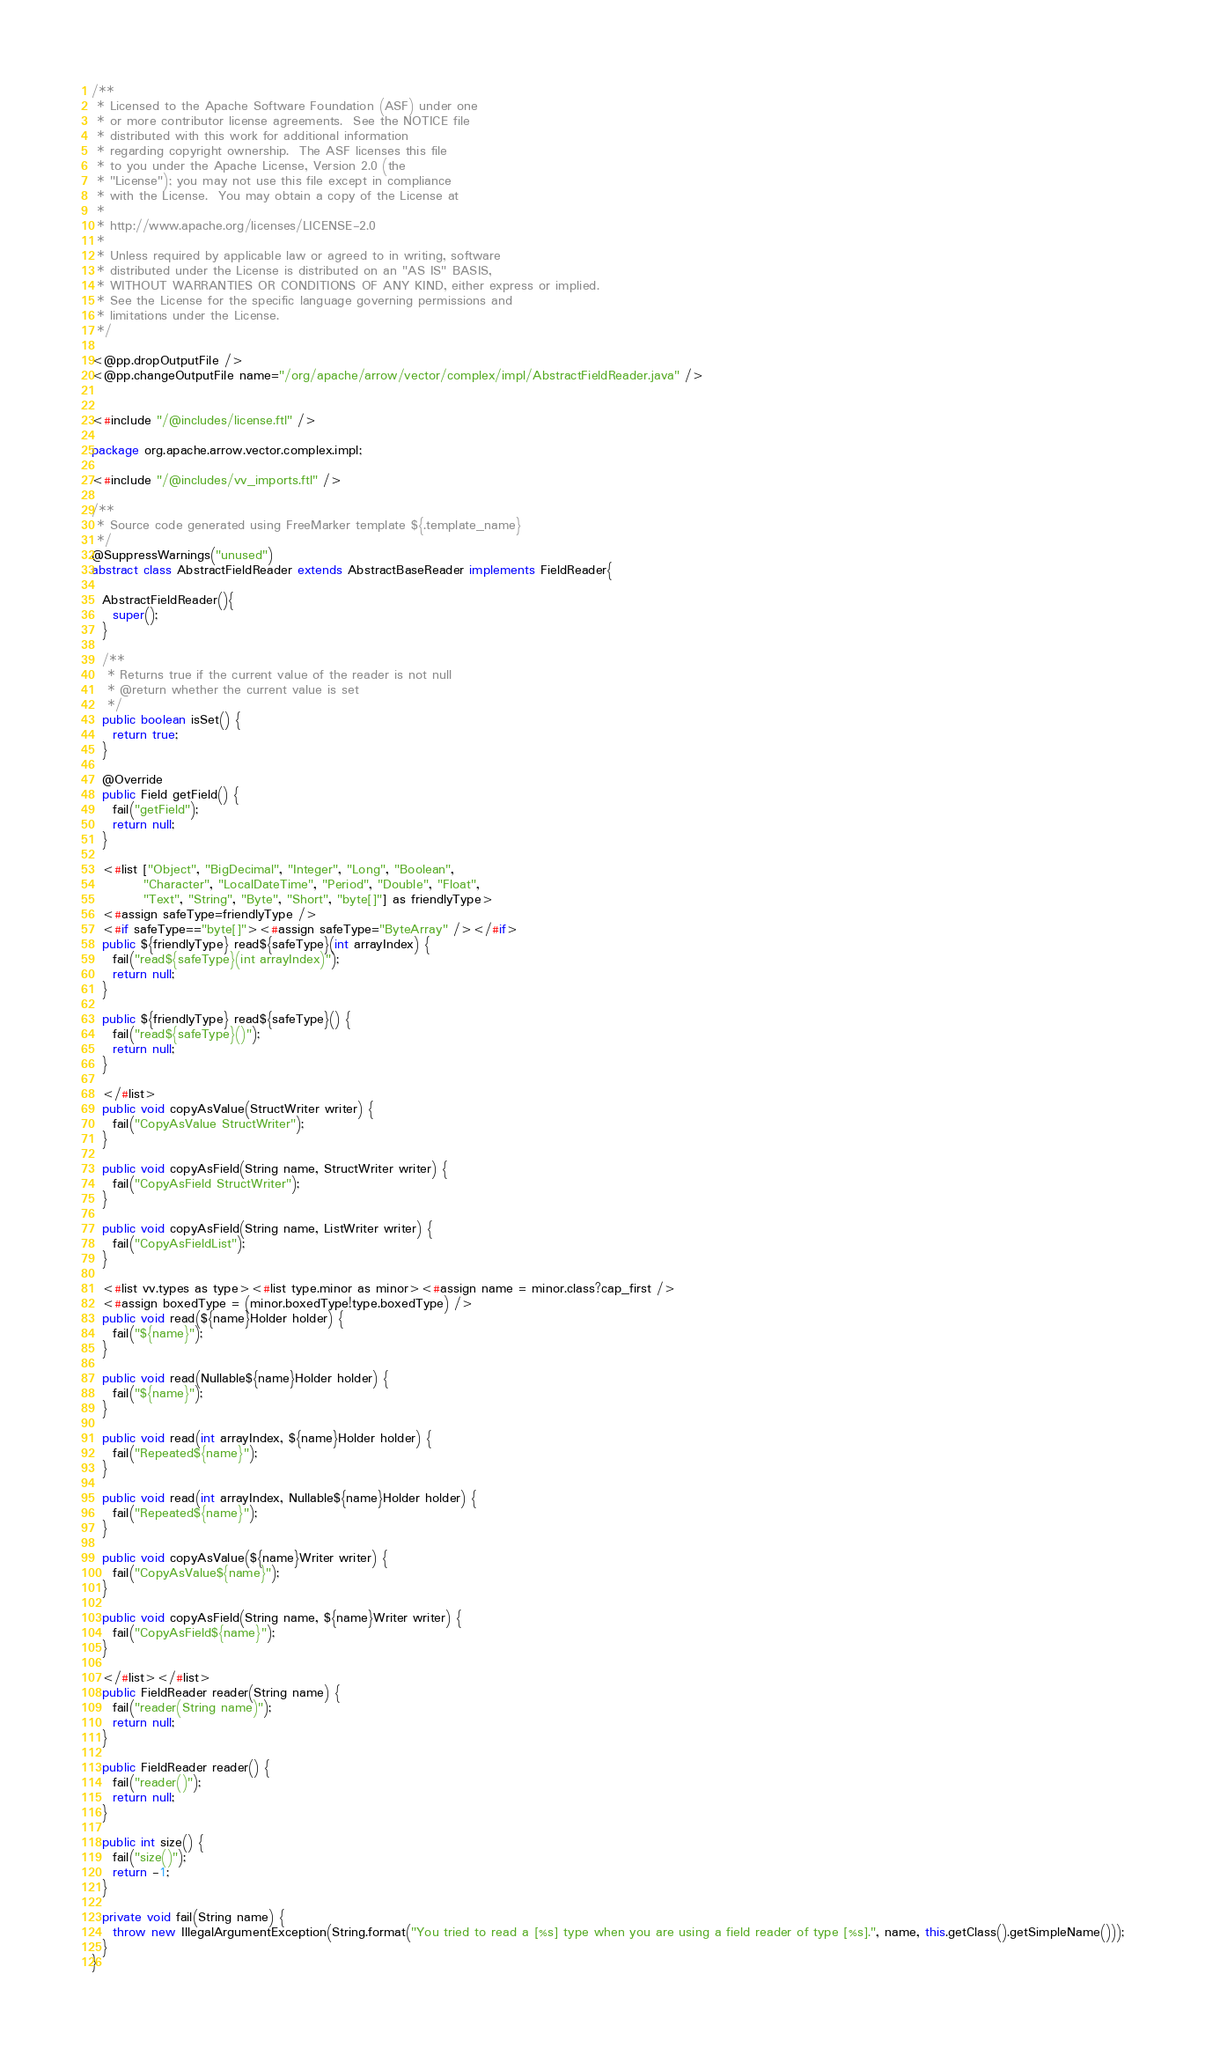Convert code to text. <code><loc_0><loc_0><loc_500><loc_500><_Java_>/**
 * Licensed to the Apache Software Foundation (ASF) under one
 * or more contributor license agreements.  See the NOTICE file
 * distributed with this work for additional information
 * regarding copyright ownership.  The ASF licenses this file
 * to you under the Apache License, Version 2.0 (the
 * "License"); you may not use this file except in compliance
 * with the License.  You may obtain a copy of the License at
 *
 * http://www.apache.org/licenses/LICENSE-2.0
 *
 * Unless required by applicable law or agreed to in writing, software
 * distributed under the License is distributed on an "AS IS" BASIS,
 * WITHOUT WARRANTIES OR CONDITIONS OF ANY KIND, either express or implied.
 * See the License for the specific language governing permissions and
 * limitations under the License.
 */

<@pp.dropOutputFile />
<@pp.changeOutputFile name="/org/apache/arrow/vector/complex/impl/AbstractFieldReader.java" />


<#include "/@includes/license.ftl" />

package org.apache.arrow.vector.complex.impl;

<#include "/@includes/vv_imports.ftl" />

/**
 * Source code generated using FreeMarker template ${.template_name}
 */
@SuppressWarnings("unused")
abstract class AbstractFieldReader extends AbstractBaseReader implements FieldReader{

  AbstractFieldReader(){
    super();
  }

  /**
   * Returns true if the current value of the reader is not null
   * @return whether the current value is set
   */
  public boolean isSet() {
    return true;
  }

  @Override
  public Field getField() {
    fail("getField");
    return null;
  }

  <#list ["Object", "BigDecimal", "Integer", "Long", "Boolean",
          "Character", "LocalDateTime", "Period", "Double", "Float",
          "Text", "String", "Byte", "Short", "byte[]"] as friendlyType>
  <#assign safeType=friendlyType />
  <#if safeType=="byte[]"><#assign safeType="ByteArray" /></#if>
  public ${friendlyType} read${safeType}(int arrayIndex) {
    fail("read${safeType}(int arrayIndex)");
    return null;
  }

  public ${friendlyType} read${safeType}() {
    fail("read${safeType}()");
    return null;
  }

  </#list>
  public void copyAsValue(StructWriter writer) {
    fail("CopyAsValue StructWriter");
  }

  public void copyAsField(String name, StructWriter writer) {
    fail("CopyAsField StructWriter");
  }

  public void copyAsField(String name, ListWriter writer) {
    fail("CopyAsFieldList");
  }

  <#list vv.types as type><#list type.minor as minor><#assign name = minor.class?cap_first />
  <#assign boxedType = (minor.boxedType!type.boxedType) />
  public void read(${name}Holder holder) {
    fail("${name}");
  }

  public void read(Nullable${name}Holder holder) {
    fail("${name}");
  }

  public void read(int arrayIndex, ${name}Holder holder) {
    fail("Repeated${name}");
  }

  public void read(int arrayIndex, Nullable${name}Holder holder) {
    fail("Repeated${name}");
  }

  public void copyAsValue(${name}Writer writer) {
    fail("CopyAsValue${name}");
  }

  public void copyAsField(String name, ${name}Writer writer) {
    fail("CopyAsField${name}");
  }

  </#list></#list>
  public FieldReader reader(String name) {
    fail("reader(String name)");
    return null;
  }

  public FieldReader reader() {
    fail("reader()");
    return null;
  }

  public int size() {
    fail("size()");
    return -1;
  }

  private void fail(String name) {
    throw new IllegalArgumentException(String.format("You tried to read a [%s] type when you are using a field reader of type [%s].", name, this.getClass().getSimpleName()));
  }
}



</code> 